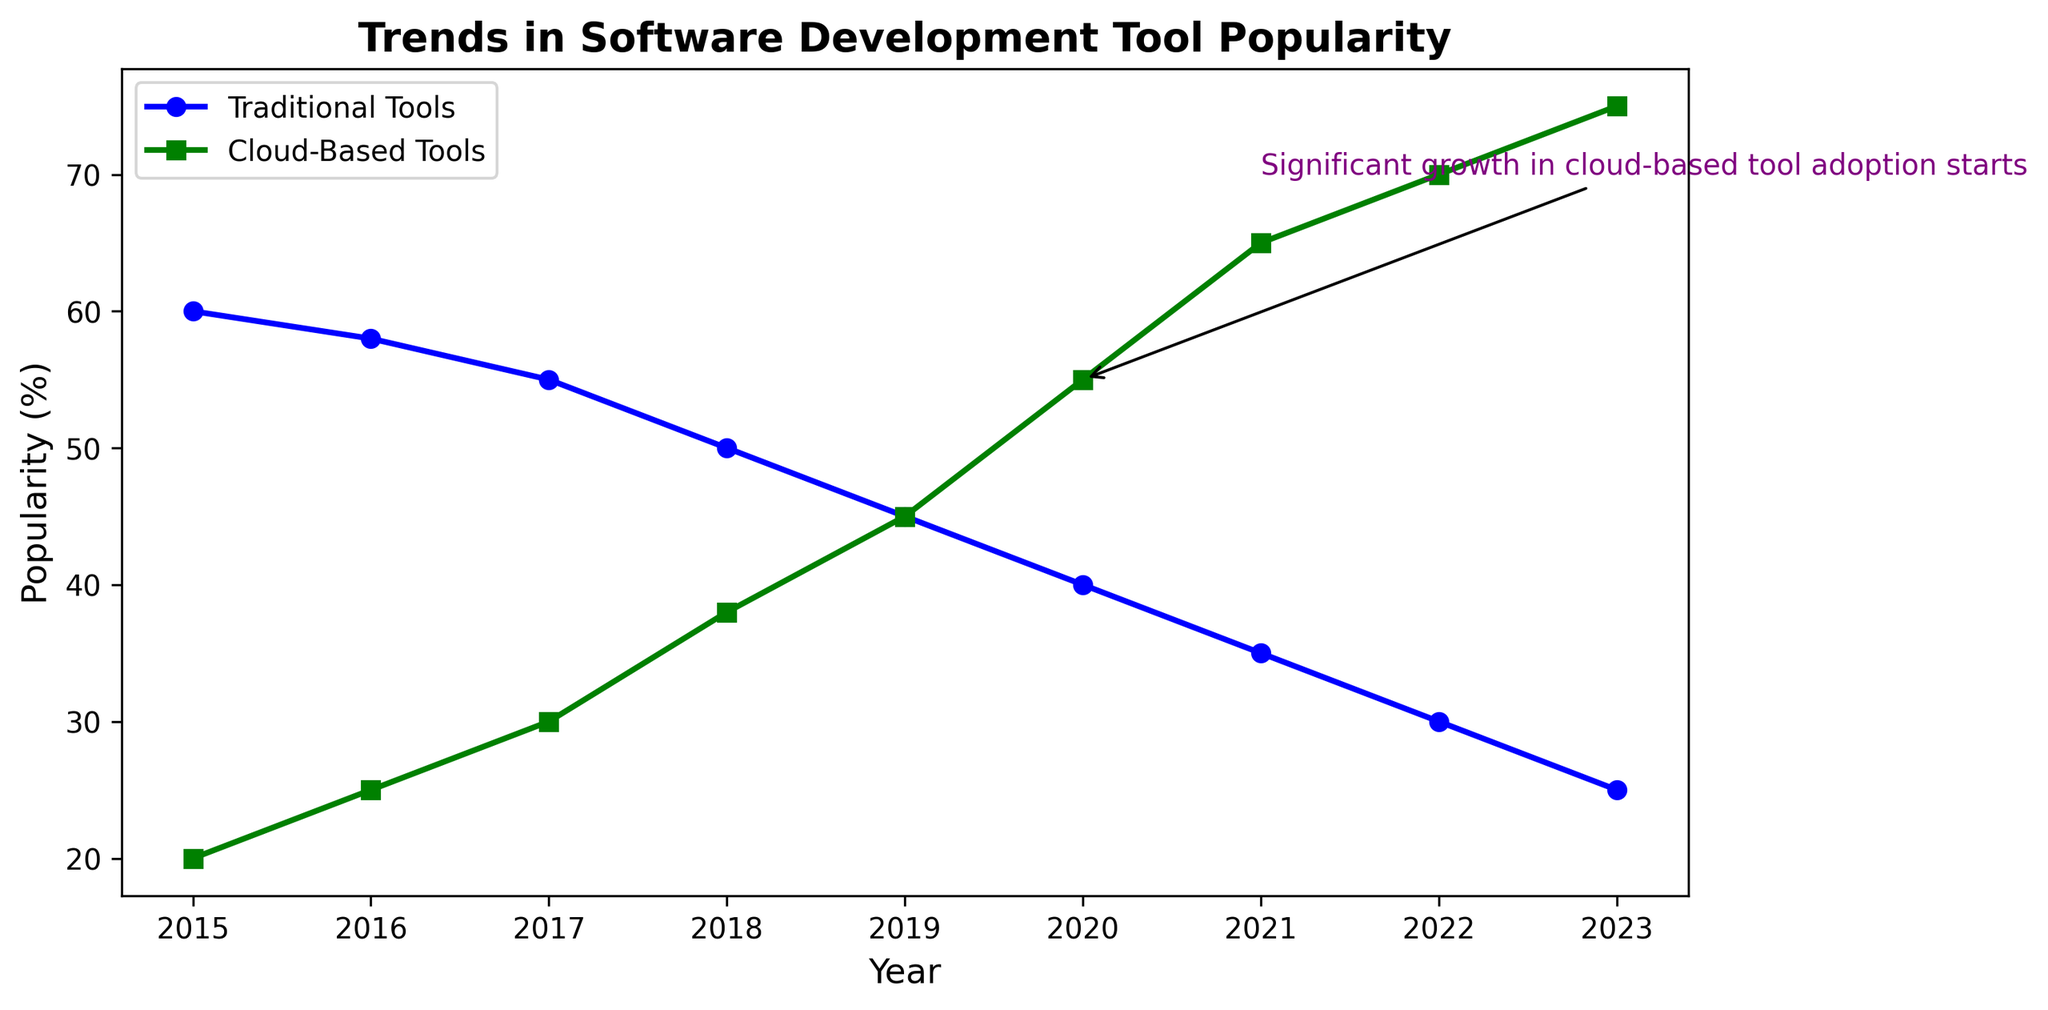What trend can you observe for cloud-based tools between 2015 and 2023? The popularity of cloud-based tools increased steadily from 20% in 2015 to 75% in 2023.
Answer: Increasing trend In which year did the popularity of traditional tools fall below that of cloud-based tools? Looking at the intersection point of the two lines, traditional tools and cloud-based tools have equal popularity in 2019.
Answer: 2019 What significant event is annotated in the plot, and in which year did it occur? The annotation "Significant growth in cloud-based tool adoption starts" highlights a notable event in 2020 when the popularity of cloud-based tools surged past traditional tools.
Answer: 2020 How much did the popularity of traditional tools decrease from 2015 to 2023? The starting value for traditional tools in 2015 was 60%. By 2023, it decreased to 25%. The difference is 60% - 25% = 35%.
Answer: 35% In which year did cloud-based tools show the highest increase in use, and what is the difference in percentage from the previous year? The highest increase occurred between 2019 and 2020, where cloud-based tools increased from 45% to 55%, which is a difference of 55% - 45% = 10%.
Answer: 2020, 10% By how much did the percentage of cloud-based tool usage exceed traditional tool usage in 2023? In 2023, cloud-based tool usage was 75%, while traditional tool usage was 25%. The difference is 75% - 25% = 50%.
Answer: 50% Between which consecutive years did the traditional tools see the sharpest decline in popularity, and what is that decline? The sharpest decline for traditional tools occurred between 2018 and 2019, where it dropped from 50% to 45%, which is a decline of 50% - 45% = 5%.
Answer: 2018-2019, 5% What is the average popularity of traditional tools from 2015 to 2023? Sum the popularity percentages for traditional tools from 2015 to 2023: (60 + 58 + 55 + 50 + 45 + 40 + 35 + 30 + 25) = 398. There are 9 years, so the average is 398 / 9 ≈ 44.22%.
Answer: 44.22% How does the trend in traditional tools compare visually to that of cloud-based tools? Visually, the line for traditional tools is decreasing while the line for cloud-based tools is increasing, indicating that traditional tools are becoming less popular as cloud-based tools gain popularity.
Answer: Traditional decreasing, Cloud-based increasing Which year had the same popularity percentage for both types of tools, and what was the percentage? In 2019, both traditional and cloud-based tools had a popularity percentage of 45%.
Answer: 2019, 45% 